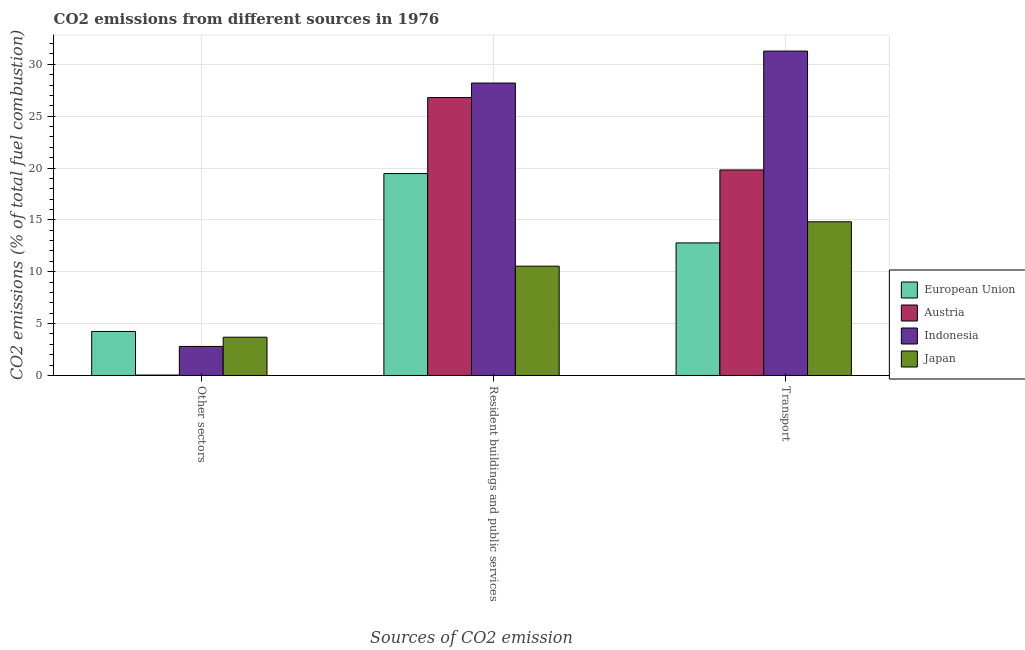How many different coloured bars are there?
Offer a terse response. 4. How many groups of bars are there?
Offer a very short reply. 3. Are the number of bars per tick equal to the number of legend labels?
Give a very brief answer. Yes. Are the number of bars on each tick of the X-axis equal?
Your response must be concise. Yes. How many bars are there on the 2nd tick from the left?
Your response must be concise. 4. What is the label of the 1st group of bars from the left?
Offer a terse response. Other sectors. What is the percentage of co2 emissions from other sectors in Japan?
Your answer should be compact. 3.69. Across all countries, what is the maximum percentage of co2 emissions from resident buildings and public services?
Provide a short and direct response. 28.19. Across all countries, what is the minimum percentage of co2 emissions from transport?
Ensure brevity in your answer.  12.78. In which country was the percentage of co2 emissions from resident buildings and public services maximum?
Offer a terse response. Indonesia. In which country was the percentage of co2 emissions from transport minimum?
Your answer should be very brief. European Union. What is the total percentage of co2 emissions from resident buildings and public services in the graph?
Make the answer very short. 84.98. What is the difference between the percentage of co2 emissions from other sectors in Austria and that in Japan?
Give a very brief answer. -3.65. What is the difference between the percentage of co2 emissions from resident buildings and public services in Indonesia and the percentage of co2 emissions from transport in European Union?
Make the answer very short. 15.41. What is the average percentage of co2 emissions from other sectors per country?
Give a very brief answer. 2.69. What is the difference between the percentage of co2 emissions from other sectors and percentage of co2 emissions from resident buildings and public services in Indonesia?
Your response must be concise. -25.39. In how many countries, is the percentage of co2 emissions from transport greater than 2 %?
Ensure brevity in your answer.  4. What is the ratio of the percentage of co2 emissions from transport in Japan to that in Austria?
Your answer should be compact. 0.75. What is the difference between the highest and the second highest percentage of co2 emissions from transport?
Provide a succinct answer. 11.46. What is the difference between the highest and the lowest percentage of co2 emissions from other sectors?
Give a very brief answer. 4.2. Is the sum of the percentage of co2 emissions from other sectors in Indonesia and European Union greater than the maximum percentage of co2 emissions from transport across all countries?
Keep it short and to the point. No. What does the 1st bar from the left in Resident buildings and public services represents?
Your answer should be very brief. European Union. What does the 2nd bar from the right in Resident buildings and public services represents?
Your answer should be very brief. Indonesia. How many countries are there in the graph?
Give a very brief answer. 4. Where does the legend appear in the graph?
Offer a terse response. Center right. What is the title of the graph?
Offer a very short reply. CO2 emissions from different sources in 1976. Does "Albania" appear as one of the legend labels in the graph?
Provide a short and direct response. No. What is the label or title of the X-axis?
Offer a terse response. Sources of CO2 emission. What is the label or title of the Y-axis?
Provide a short and direct response. CO2 emissions (% of total fuel combustion). What is the CO2 emissions (% of total fuel combustion) of European Union in Other sectors?
Provide a short and direct response. 4.24. What is the CO2 emissions (% of total fuel combustion) of Austria in Other sectors?
Your answer should be very brief. 0.04. What is the CO2 emissions (% of total fuel combustion) of Indonesia in Other sectors?
Your response must be concise. 2.8. What is the CO2 emissions (% of total fuel combustion) in Japan in Other sectors?
Your answer should be compact. 3.69. What is the CO2 emissions (% of total fuel combustion) of European Union in Resident buildings and public services?
Offer a very short reply. 19.47. What is the CO2 emissions (% of total fuel combustion) in Austria in Resident buildings and public services?
Provide a short and direct response. 26.79. What is the CO2 emissions (% of total fuel combustion) in Indonesia in Resident buildings and public services?
Offer a very short reply. 28.19. What is the CO2 emissions (% of total fuel combustion) in Japan in Resident buildings and public services?
Give a very brief answer. 10.54. What is the CO2 emissions (% of total fuel combustion) of European Union in Transport?
Provide a short and direct response. 12.78. What is the CO2 emissions (% of total fuel combustion) of Austria in Transport?
Offer a terse response. 19.81. What is the CO2 emissions (% of total fuel combustion) in Indonesia in Transport?
Your answer should be compact. 31.27. What is the CO2 emissions (% of total fuel combustion) of Japan in Transport?
Your answer should be compact. 14.81. Across all Sources of CO2 emission, what is the maximum CO2 emissions (% of total fuel combustion) of European Union?
Your answer should be compact. 19.47. Across all Sources of CO2 emission, what is the maximum CO2 emissions (% of total fuel combustion) in Austria?
Provide a short and direct response. 26.79. Across all Sources of CO2 emission, what is the maximum CO2 emissions (% of total fuel combustion) in Indonesia?
Offer a very short reply. 31.27. Across all Sources of CO2 emission, what is the maximum CO2 emissions (% of total fuel combustion) in Japan?
Provide a short and direct response. 14.81. Across all Sources of CO2 emission, what is the minimum CO2 emissions (% of total fuel combustion) in European Union?
Offer a terse response. 4.24. Across all Sources of CO2 emission, what is the minimum CO2 emissions (% of total fuel combustion) of Austria?
Give a very brief answer. 0.04. Across all Sources of CO2 emission, what is the minimum CO2 emissions (% of total fuel combustion) in Indonesia?
Your answer should be compact. 2.8. Across all Sources of CO2 emission, what is the minimum CO2 emissions (% of total fuel combustion) of Japan?
Provide a succinct answer. 3.69. What is the total CO2 emissions (% of total fuel combustion) of European Union in the graph?
Your answer should be compact. 36.49. What is the total CO2 emissions (% of total fuel combustion) in Austria in the graph?
Ensure brevity in your answer.  46.64. What is the total CO2 emissions (% of total fuel combustion) in Indonesia in the graph?
Give a very brief answer. 62.26. What is the total CO2 emissions (% of total fuel combustion) in Japan in the graph?
Give a very brief answer. 29.04. What is the difference between the CO2 emissions (% of total fuel combustion) in European Union in Other sectors and that in Resident buildings and public services?
Ensure brevity in your answer.  -15.22. What is the difference between the CO2 emissions (% of total fuel combustion) of Austria in Other sectors and that in Resident buildings and public services?
Keep it short and to the point. -26.75. What is the difference between the CO2 emissions (% of total fuel combustion) in Indonesia in Other sectors and that in Resident buildings and public services?
Give a very brief answer. -25.39. What is the difference between the CO2 emissions (% of total fuel combustion) in Japan in Other sectors and that in Resident buildings and public services?
Give a very brief answer. -6.85. What is the difference between the CO2 emissions (% of total fuel combustion) of European Union in Other sectors and that in Transport?
Offer a terse response. -8.54. What is the difference between the CO2 emissions (% of total fuel combustion) in Austria in Other sectors and that in Transport?
Provide a succinct answer. -19.78. What is the difference between the CO2 emissions (% of total fuel combustion) of Indonesia in Other sectors and that in Transport?
Keep it short and to the point. -28.47. What is the difference between the CO2 emissions (% of total fuel combustion) in Japan in Other sectors and that in Transport?
Keep it short and to the point. -11.13. What is the difference between the CO2 emissions (% of total fuel combustion) in European Union in Resident buildings and public services and that in Transport?
Give a very brief answer. 6.69. What is the difference between the CO2 emissions (% of total fuel combustion) in Austria in Resident buildings and public services and that in Transport?
Ensure brevity in your answer.  6.98. What is the difference between the CO2 emissions (% of total fuel combustion) in Indonesia in Resident buildings and public services and that in Transport?
Your answer should be compact. -3.08. What is the difference between the CO2 emissions (% of total fuel combustion) of Japan in Resident buildings and public services and that in Transport?
Provide a short and direct response. -4.28. What is the difference between the CO2 emissions (% of total fuel combustion) of European Union in Other sectors and the CO2 emissions (% of total fuel combustion) of Austria in Resident buildings and public services?
Your answer should be very brief. -22.55. What is the difference between the CO2 emissions (% of total fuel combustion) of European Union in Other sectors and the CO2 emissions (% of total fuel combustion) of Indonesia in Resident buildings and public services?
Offer a terse response. -23.95. What is the difference between the CO2 emissions (% of total fuel combustion) of European Union in Other sectors and the CO2 emissions (% of total fuel combustion) of Japan in Resident buildings and public services?
Provide a short and direct response. -6.29. What is the difference between the CO2 emissions (% of total fuel combustion) in Austria in Other sectors and the CO2 emissions (% of total fuel combustion) in Indonesia in Resident buildings and public services?
Provide a short and direct response. -28.15. What is the difference between the CO2 emissions (% of total fuel combustion) of Austria in Other sectors and the CO2 emissions (% of total fuel combustion) of Japan in Resident buildings and public services?
Your answer should be very brief. -10.5. What is the difference between the CO2 emissions (% of total fuel combustion) of Indonesia in Other sectors and the CO2 emissions (% of total fuel combustion) of Japan in Resident buildings and public services?
Provide a succinct answer. -7.74. What is the difference between the CO2 emissions (% of total fuel combustion) in European Union in Other sectors and the CO2 emissions (% of total fuel combustion) in Austria in Transport?
Keep it short and to the point. -15.57. What is the difference between the CO2 emissions (% of total fuel combustion) in European Union in Other sectors and the CO2 emissions (% of total fuel combustion) in Indonesia in Transport?
Your answer should be compact. -27.03. What is the difference between the CO2 emissions (% of total fuel combustion) of European Union in Other sectors and the CO2 emissions (% of total fuel combustion) of Japan in Transport?
Provide a short and direct response. -10.57. What is the difference between the CO2 emissions (% of total fuel combustion) in Austria in Other sectors and the CO2 emissions (% of total fuel combustion) in Indonesia in Transport?
Your answer should be compact. -31.23. What is the difference between the CO2 emissions (% of total fuel combustion) of Austria in Other sectors and the CO2 emissions (% of total fuel combustion) of Japan in Transport?
Your response must be concise. -14.78. What is the difference between the CO2 emissions (% of total fuel combustion) of Indonesia in Other sectors and the CO2 emissions (% of total fuel combustion) of Japan in Transport?
Offer a very short reply. -12.02. What is the difference between the CO2 emissions (% of total fuel combustion) of European Union in Resident buildings and public services and the CO2 emissions (% of total fuel combustion) of Austria in Transport?
Offer a terse response. -0.35. What is the difference between the CO2 emissions (% of total fuel combustion) of European Union in Resident buildings and public services and the CO2 emissions (% of total fuel combustion) of Indonesia in Transport?
Offer a terse response. -11.81. What is the difference between the CO2 emissions (% of total fuel combustion) of European Union in Resident buildings and public services and the CO2 emissions (% of total fuel combustion) of Japan in Transport?
Ensure brevity in your answer.  4.65. What is the difference between the CO2 emissions (% of total fuel combustion) in Austria in Resident buildings and public services and the CO2 emissions (% of total fuel combustion) in Indonesia in Transport?
Your answer should be very brief. -4.48. What is the difference between the CO2 emissions (% of total fuel combustion) in Austria in Resident buildings and public services and the CO2 emissions (% of total fuel combustion) in Japan in Transport?
Make the answer very short. 11.98. What is the difference between the CO2 emissions (% of total fuel combustion) of Indonesia in Resident buildings and public services and the CO2 emissions (% of total fuel combustion) of Japan in Transport?
Your answer should be very brief. 13.38. What is the average CO2 emissions (% of total fuel combustion) in European Union per Sources of CO2 emission?
Ensure brevity in your answer.  12.16. What is the average CO2 emissions (% of total fuel combustion) of Austria per Sources of CO2 emission?
Make the answer very short. 15.55. What is the average CO2 emissions (% of total fuel combustion) in Indonesia per Sources of CO2 emission?
Your answer should be compact. 20.75. What is the average CO2 emissions (% of total fuel combustion) of Japan per Sources of CO2 emission?
Keep it short and to the point. 9.68. What is the difference between the CO2 emissions (% of total fuel combustion) of European Union and CO2 emissions (% of total fuel combustion) of Austria in Other sectors?
Offer a very short reply. 4.2. What is the difference between the CO2 emissions (% of total fuel combustion) of European Union and CO2 emissions (% of total fuel combustion) of Indonesia in Other sectors?
Your answer should be very brief. 1.44. What is the difference between the CO2 emissions (% of total fuel combustion) in European Union and CO2 emissions (% of total fuel combustion) in Japan in Other sectors?
Give a very brief answer. 0.55. What is the difference between the CO2 emissions (% of total fuel combustion) of Austria and CO2 emissions (% of total fuel combustion) of Indonesia in Other sectors?
Keep it short and to the point. -2.76. What is the difference between the CO2 emissions (% of total fuel combustion) of Austria and CO2 emissions (% of total fuel combustion) of Japan in Other sectors?
Offer a very short reply. -3.65. What is the difference between the CO2 emissions (% of total fuel combustion) of Indonesia and CO2 emissions (% of total fuel combustion) of Japan in Other sectors?
Make the answer very short. -0.89. What is the difference between the CO2 emissions (% of total fuel combustion) of European Union and CO2 emissions (% of total fuel combustion) of Austria in Resident buildings and public services?
Ensure brevity in your answer.  -7.33. What is the difference between the CO2 emissions (% of total fuel combustion) in European Union and CO2 emissions (% of total fuel combustion) in Indonesia in Resident buildings and public services?
Keep it short and to the point. -8.72. What is the difference between the CO2 emissions (% of total fuel combustion) in European Union and CO2 emissions (% of total fuel combustion) in Japan in Resident buildings and public services?
Provide a succinct answer. 8.93. What is the difference between the CO2 emissions (% of total fuel combustion) of Austria and CO2 emissions (% of total fuel combustion) of Indonesia in Resident buildings and public services?
Your answer should be compact. -1.4. What is the difference between the CO2 emissions (% of total fuel combustion) of Austria and CO2 emissions (% of total fuel combustion) of Japan in Resident buildings and public services?
Ensure brevity in your answer.  16.25. What is the difference between the CO2 emissions (% of total fuel combustion) in Indonesia and CO2 emissions (% of total fuel combustion) in Japan in Resident buildings and public services?
Your answer should be compact. 17.65. What is the difference between the CO2 emissions (% of total fuel combustion) of European Union and CO2 emissions (% of total fuel combustion) of Austria in Transport?
Your answer should be compact. -7.03. What is the difference between the CO2 emissions (% of total fuel combustion) of European Union and CO2 emissions (% of total fuel combustion) of Indonesia in Transport?
Ensure brevity in your answer.  -18.49. What is the difference between the CO2 emissions (% of total fuel combustion) in European Union and CO2 emissions (% of total fuel combustion) in Japan in Transport?
Your answer should be very brief. -2.04. What is the difference between the CO2 emissions (% of total fuel combustion) of Austria and CO2 emissions (% of total fuel combustion) of Indonesia in Transport?
Give a very brief answer. -11.46. What is the difference between the CO2 emissions (% of total fuel combustion) in Austria and CO2 emissions (% of total fuel combustion) in Japan in Transport?
Keep it short and to the point. 5. What is the difference between the CO2 emissions (% of total fuel combustion) in Indonesia and CO2 emissions (% of total fuel combustion) in Japan in Transport?
Give a very brief answer. 16.46. What is the ratio of the CO2 emissions (% of total fuel combustion) in European Union in Other sectors to that in Resident buildings and public services?
Provide a succinct answer. 0.22. What is the ratio of the CO2 emissions (% of total fuel combustion) of Austria in Other sectors to that in Resident buildings and public services?
Your answer should be very brief. 0. What is the ratio of the CO2 emissions (% of total fuel combustion) in Indonesia in Other sectors to that in Resident buildings and public services?
Provide a succinct answer. 0.1. What is the ratio of the CO2 emissions (% of total fuel combustion) in Japan in Other sectors to that in Resident buildings and public services?
Your response must be concise. 0.35. What is the ratio of the CO2 emissions (% of total fuel combustion) in European Union in Other sectors to that in Transport?
Offer a terse response. 0.33. What is the ratio of the CO2 emissions (% of total fuel combustion) of Austria in Other sectors to that in Transport?
Offer a terse response. 0. What is the ratio of the CO2 emissions (% of total fuel combustion) in Indonesia in Other sectors to that in Transport?
Keep it short and to the point. 0.09. What is the ratio of the CO2 emissions (% of total fuel combustion) of Japan in Other sectors to that in Transport?
Your answer should be compact. 0.25. What is the ratio of the CO2 emissions (% of total fuel combustion) of European Union in Resident buildings and public services to that in Transport?
Offer a terse response. 1.52. What is the ratio of the CO2 emissions (% of total fuel combustion) in Austria in Resident buildings and public services to that in Transport?
Your answer should be compact. 1.35. What is the ratio of the CO2 emissions (% of total fuel combustion) of Indonesia in Resident buildings and public services to that in Transport?
Provide a succinct answer. 0.9. What is the ratio of the CO2 emissions (% of total fuel combustion) in Japan in Resident buildings and public services to that in Transport?
Provide a succinct answer. 0.71. What is the difference between the highest and the second highest CO2 emissions (% of total fuel combustion) of European Union?
Provide a short and direct response. 6.69. What is the difference between the highest and the second highest CO2 emissions (% of total fuel combustion) in Austria?
Your answer should be very brief. 6.98. What is the difference between the highest and the second highest CO2 emissions (% of total fuel combustion) of Indonesia?
Your answer should be compact. 3.08. What is the difference between the highest and the second highest CO2 emissions (% of total fuel combustion) in Japan?
Ensure brevity in your answer.  4.28. What is the difference between the highest and the lowest CO2 emissions (% of total fuel combustion) in European Union?
Offer a terse response. 15.22. What is the difference between the highest and the lowest CO2 emissions (% of total fuel combustion) of Austria?
Provide a short and direct response. 26.75. What is the difference between the highest and the lowest CO2 emissions (% of total fuel combustion) of Indonesia?
Ensure brevity in your answer.  28.47. What is the difference between the highest and the lowest CO2 emissions (% of total fuel combustion) in Japan?
Provide a succinct answer. 11.13. 